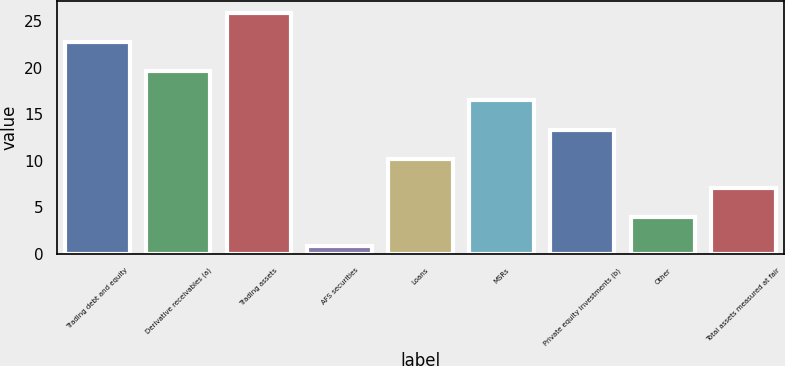Convert chart to OTSL. <chart><loc_0><loc_0><loc_500><loc_500><bar_chart><fcel>Trading debt and equity<fcel>Derivative receivables (a)<fcel>Trading assets<fcel>AFS securities<fcel>Loans<fcel>MSRs<fcel>Private equity investments (b)<fcel>Other<fcel>Total assets measured at fair<nl><fcel>22.78<fcel>19.64<fcel>25.92<fcel>0.8<fcel>10.22<fcel>16.5<fcel>13.36<fcel>3.94<fcel>7.08<nl></chart> 